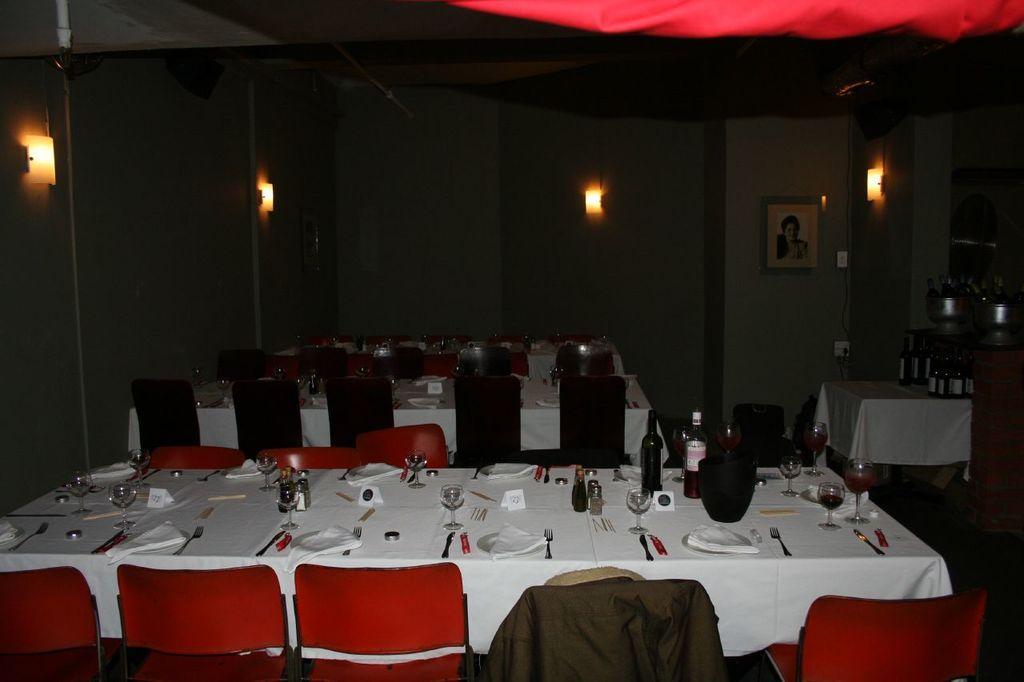Please provide a concise description of this image. In this image, we can see some tables covered with a cloth and some objects like glasses and spoons are placed on it. We can also see some chairs. We can see some glasses on the right. We can also see the wall with some lights and a photo frame. We can also see the roof. We can also see some object at the top right corner. 